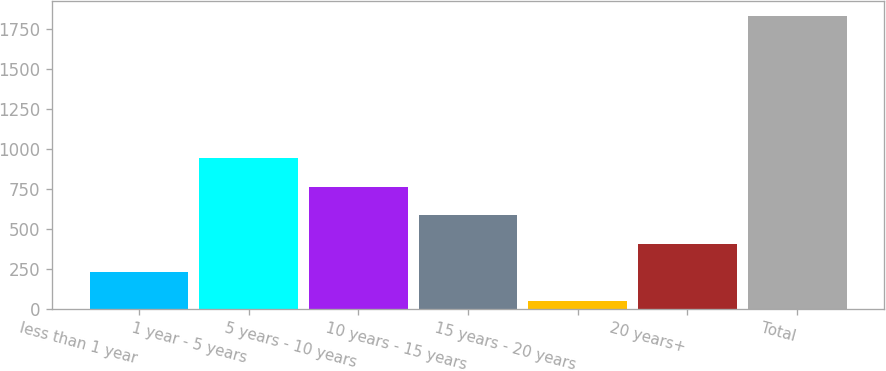Convert chart to OTSL. <chart><loc_0><loc_0><loc_500><loc_500><bar_chart><fcel>less than 1 year<fcel>1 year - 5 years<fcel>5 years - 10 years<fcel>10 years - 15 years<fcel>15 years - 20 years<fcel>20 years+<fcel>Total<nl><fcel>229.8<fcel>941<fcel>763.2<fcel>585.4<fcel>52<fcel>407.6<fcel>1830<nl></chart> 